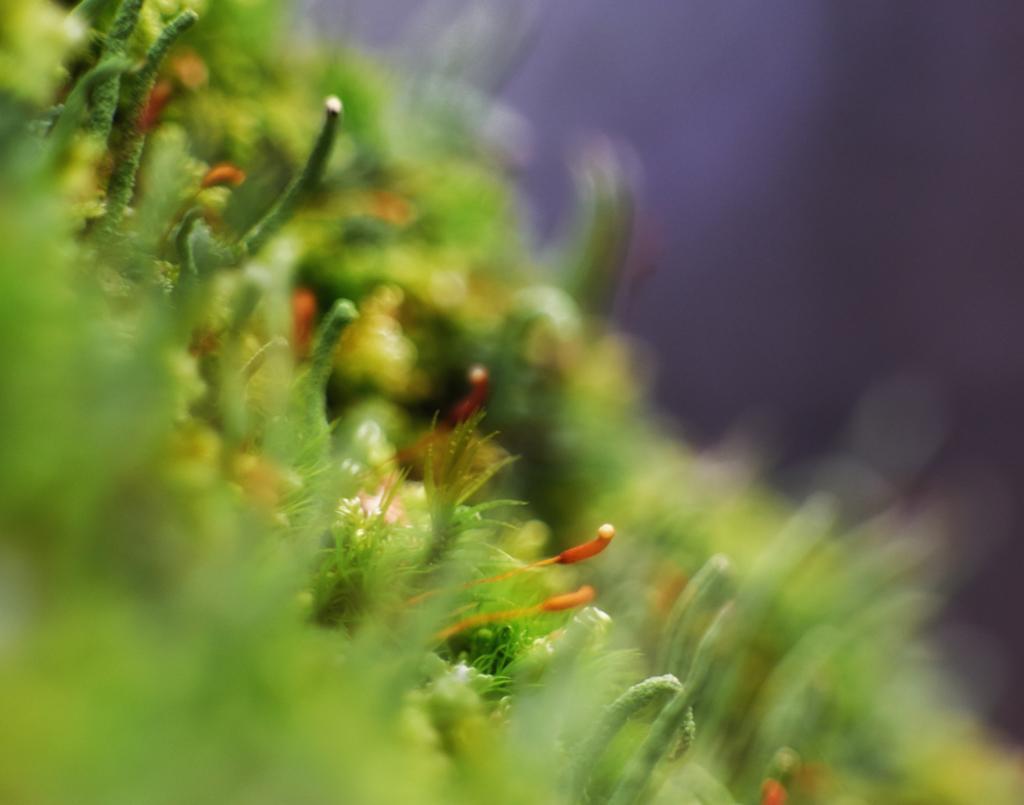Could you give a brief overview of what you see in this image? It is a blurry image and we can see greenery. 